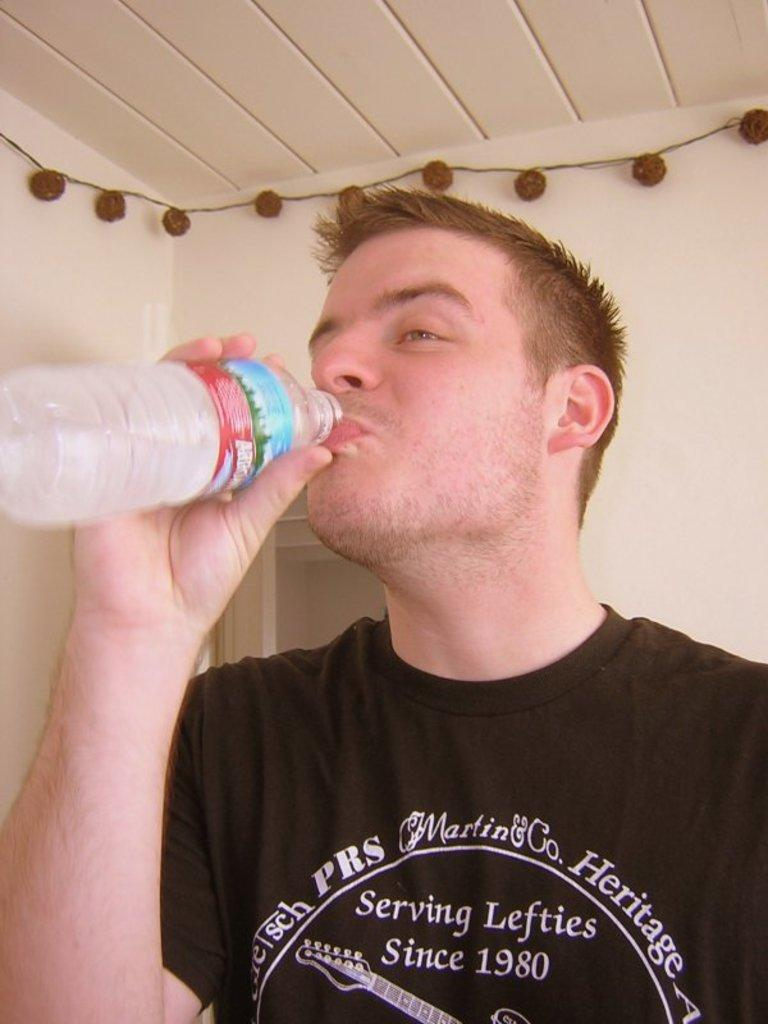Who is present in the image? There is a man in the image. What is the man doing in the image? The man is drinking water from a water bottle. What can be seen in the background of the image? There is a wall in the background of the image. What is on the wall in the image? There are decorative items on the wall. How many rabbits are sitting on the man's head in the image? There are no rabbits present in the image, and the man's head is not visible. 